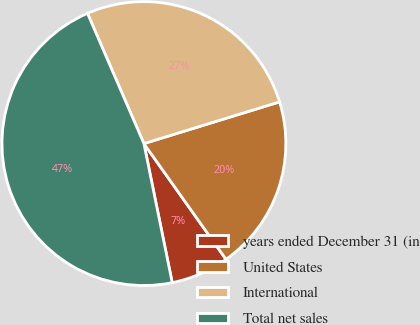<chart> <loc_0><loc_0><loc_500><loc_500><pie_chart><fcel>years ended December 31 (in<fcel>United States<fcel>International<fcel>Total net sales<nl><fcel>6.62%<fcel>19.93%<fcel>26.76%<fcel>46.69%<nl></chart> 